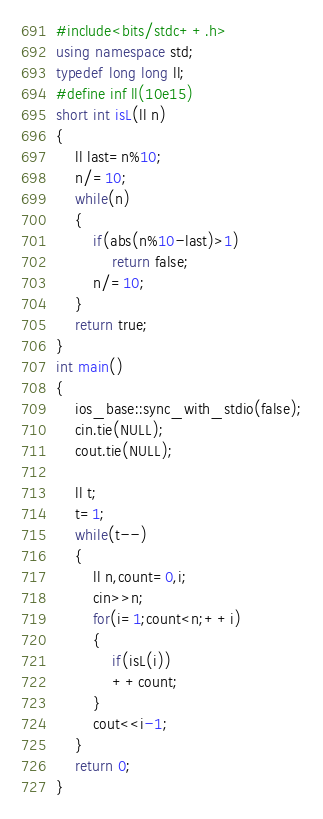<code> <loc_0><loc_0><loc_500><loc_500><_C++_>#include<bits/stdc++.h>
using namespace std;
typedef long long ll;
#define inf ll(10e15)
short int isL(ll n)
{
    ll last=n%10;
    n/=10;
    while(n)
    {
        if(abs(n%10-last)>1)
            return false;
        n/=10;
    }
    return true;
}
int main()
{
    ios_base::sync_with_stdio(false);
    cin.tie(NULL);
    cout.tie(NULL);

    ll t;
    t=1;
    while(t--)
    {
        ll n,count=0,i;
        cin>>n;
        for(i=1;count<n;++i)
        {
            if(isL(i))
            ++count;
        }
        cout<<i-1;
    }
    return 0;
}
</code> 